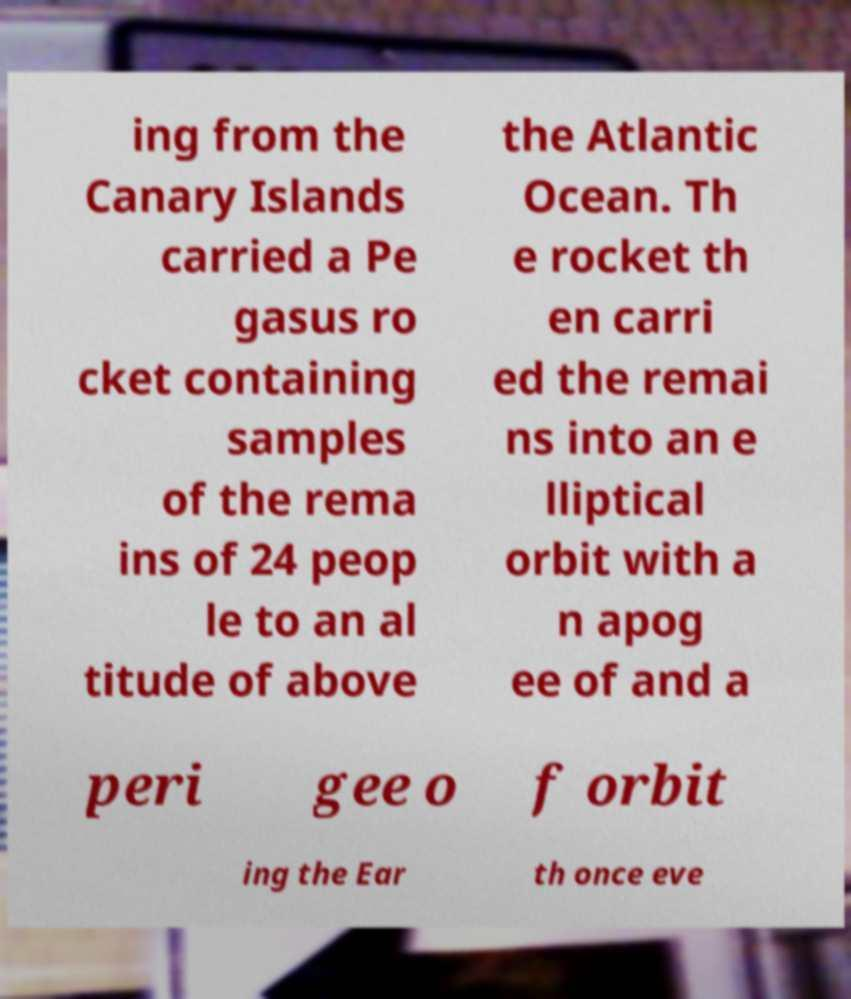I need the written content from this picture converted into text. Can you do that? ing from the Canary Islands carried a Pe gasus ro cket containing samples of the rema ins of 24 peop le to an al titude of above the Atlantic Ocean. Th e rocket th en carri ed the remai ns into an e lliptical orbit with a n apog ee of and a peri gee o f orbit ing the Ear th once eve 